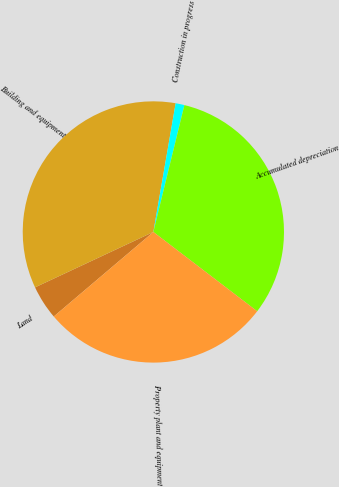Convert chart to OTSL. <chart><loc_0><loc_0><loc_500><loc_500><pie_chart><fcel>Land<fcel>Building and equipment<fcel>Construction in progress<fcel>Accumulated depreciation<fcel>Property plant and equipment<nl><fcel>4.23%<fcel>34.7%<fcel>1.09%<fcel>31.56%<fcel>28.42%<nl></chart> 